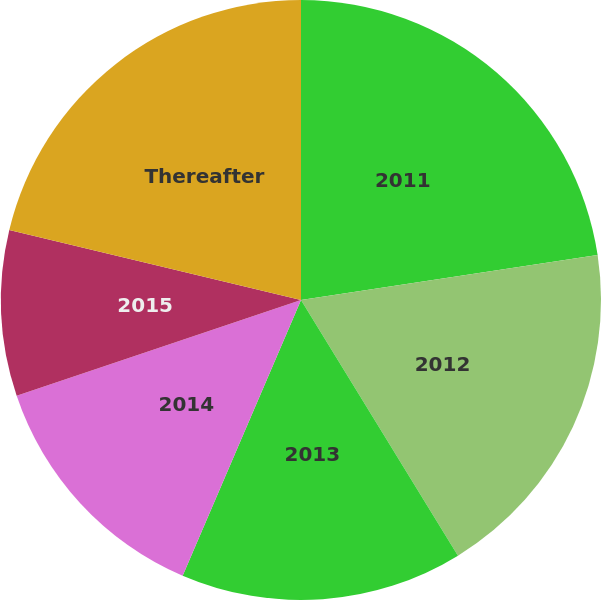Convert chart to OTSL. <chart><loc_0><loc_0><loc_500><loc_500><pie_chart><fcel>2011<fcel>2012<fcel>2013<fcel>2014<fcel>2015<fcel>Thereafter<nl><fcel>22.61%<fcel>18.63%<fcel>15.22%<fcel>13.38%<fcel>8.92%<fcel>21.25%<nl></chart> 